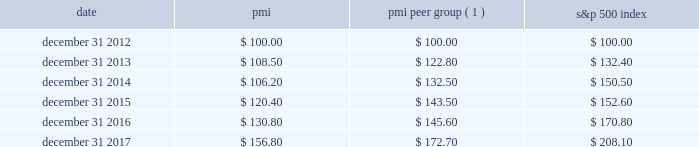Performance graph the graph below compares the cumulative total shareholder return on pmi's common stock with the cumulative total return for the same period of pmi's peer group and the s&p 500 index .
The graph assumes the investment of $ 100 as of december 31 , 2012 , in pmi common stock ( at prices quoted on the new york stock exchange ) and each of the indices as of the market close and reinvestment of dividends on a quarterly basis .
Date pmi pmi peer group ( 1 ) s&p 500 index .
( 1 ) the pmi peer group presented in this graph is the same as that used in the prior year , except reynolds american inc .
Was removed following the completion of its acquisition by british american tobacco p.l.c .
On july 25 , 2017 .
The pmi peer group was established based on a review of four characteristics : global presence ; a focus on consumer products ; and net revenues and a market capitalization of a similar size to those of pmi .
The review also considered the primary international tobacco companies .
As a result of this review , the following companies constitute the pmi peer group : altria group , inc. , anheuser-busch inbev sa/nv , british american tobacco p.l.c. , the coca-cola company , colgate-palmolive co. , diageo plc , heineken n.v. , imperial brands plc , japan tobacco inc. , johnson & johnson , kimberly-clark corporation , the kraft-heinz company , mcdonald's corp. , mondel z international , inc. , nestl e9 s.a. , pepsico , inc. , the procter & gamble company , roche holding ag , and unilever nv and plc .
Note : figures are rounded to the nearest $ 0.10. .
What is the growth rate in pmi's share price from 2014 to 2015? 
Computations: ((120.40 - 106.20) / 106.20)
Answer: 0.13371. 